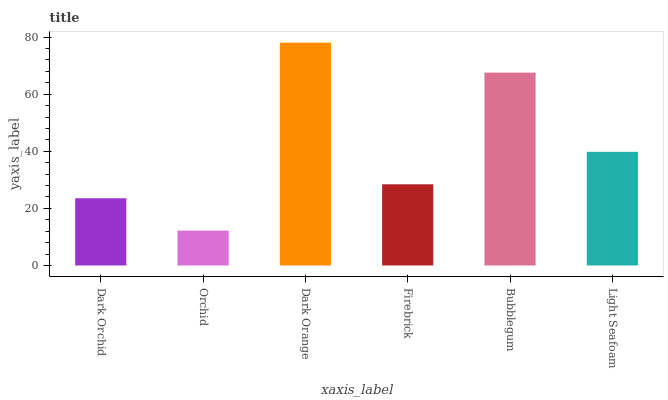Is Orchid the minimum?
Answer yes or no. Yes. Is Dark Orange the maximum?
Answer yes or no. Yes. Is Dark Orange the minimum?
Answer yes or no. No. Is Orchid the maximum?
Answer yes or no. No. Is Dark Orange greater than Orchid?
Answer yes or no. Yes. Is Orchid less than Dark Orange?
Answer yes or no. Yes. Is Orchid greater than Dark Orange?
Answer yes or no. No. Is Dark Orange less than Orchid?
Answer yes or no. No. Is Light Seafoam the high median?
Answer yes or no. Yes. Is Firebrick the low median?
Answer yes or no. Yes. Is Firebrick the high median?
Answer yes or no. No. Is Light Seafoam the low median?
Answer yes or no. No. 